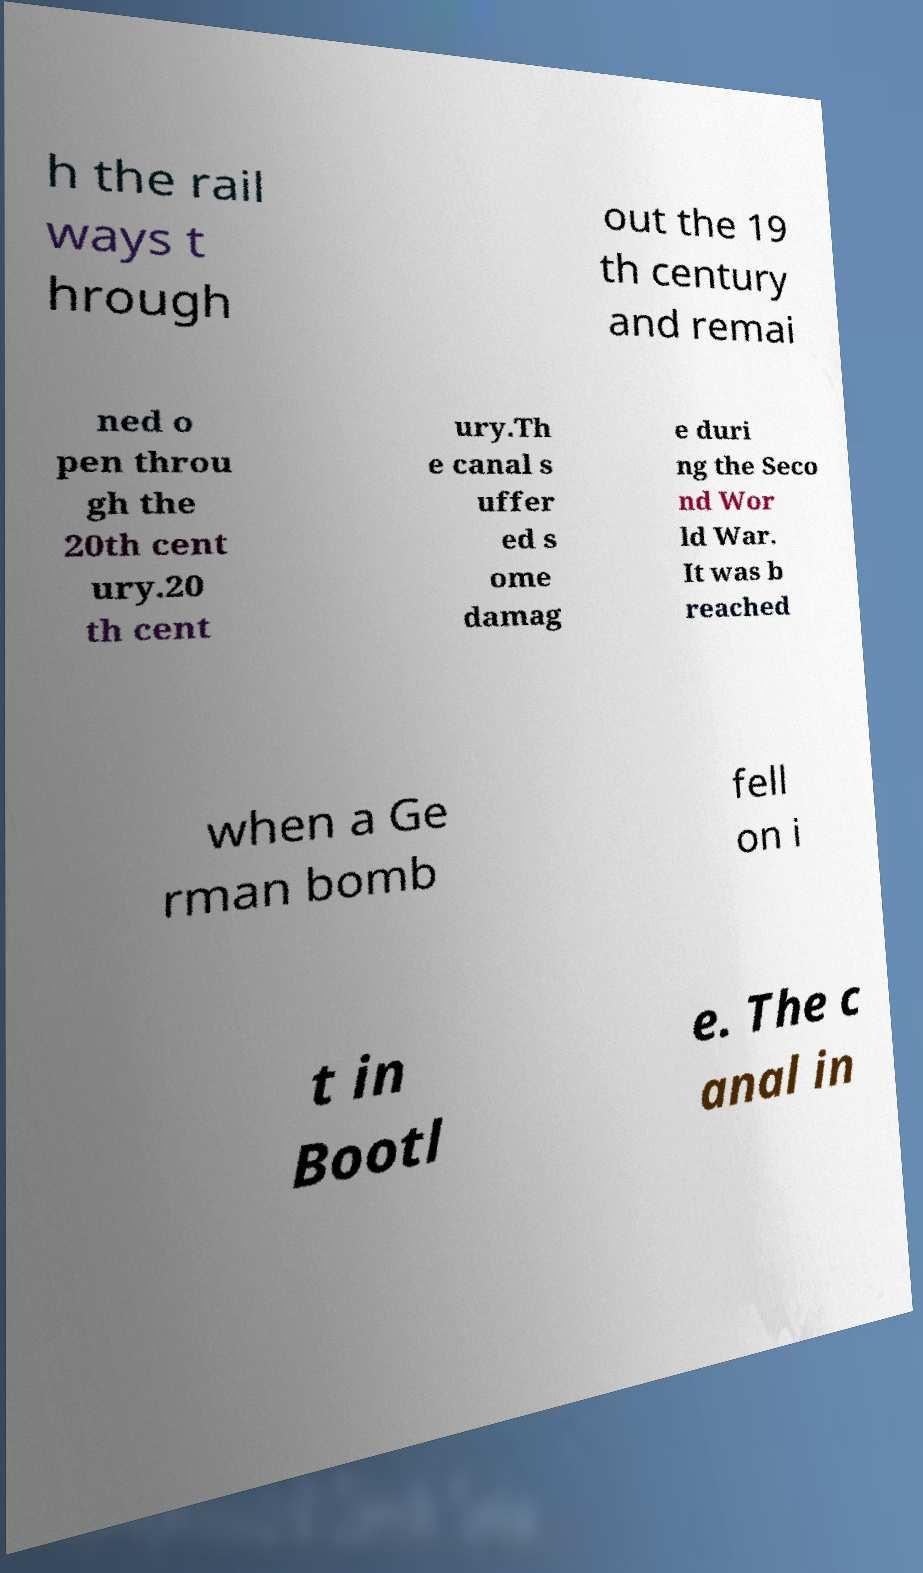Please read and relay the text visible in this image. What does it say? h the rail ways t hrough out the 19 th century and remai ned o pen throu gh the 20th cent ury.20 th cent ury.Th e canal s uffer ed s ome damag e duri ng the Seco nd Wor ld War. It was b reached when a Ge rman bomb fell on i t in Bootl e. The c anal in 